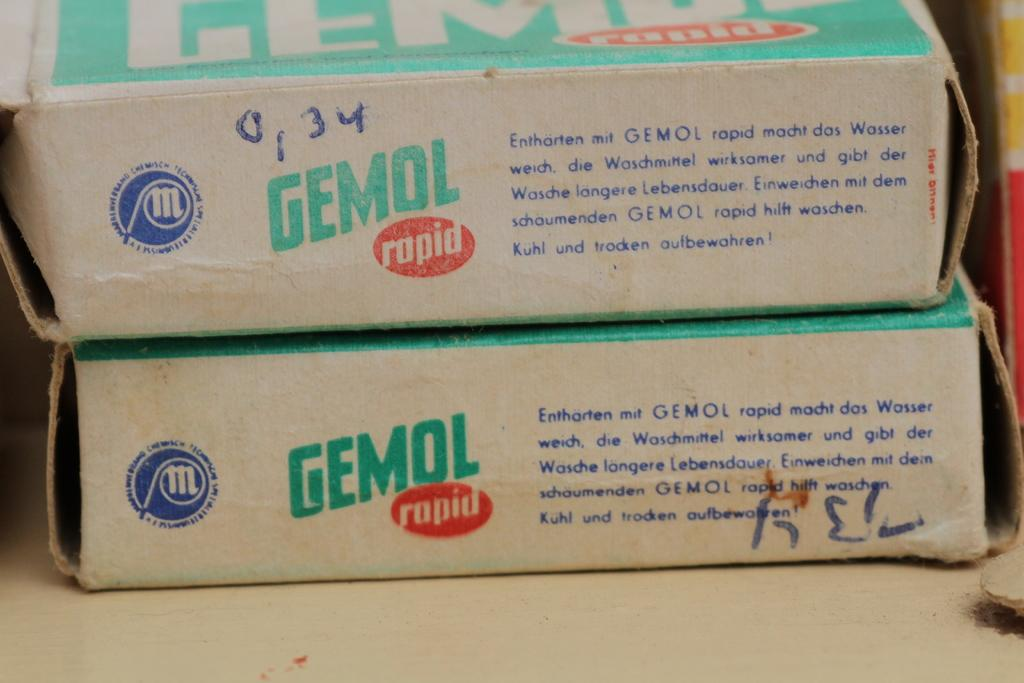Provide a one-sentence caption for the provided image. A side on image of two Gemol boxes with German text explaining what they contain. 